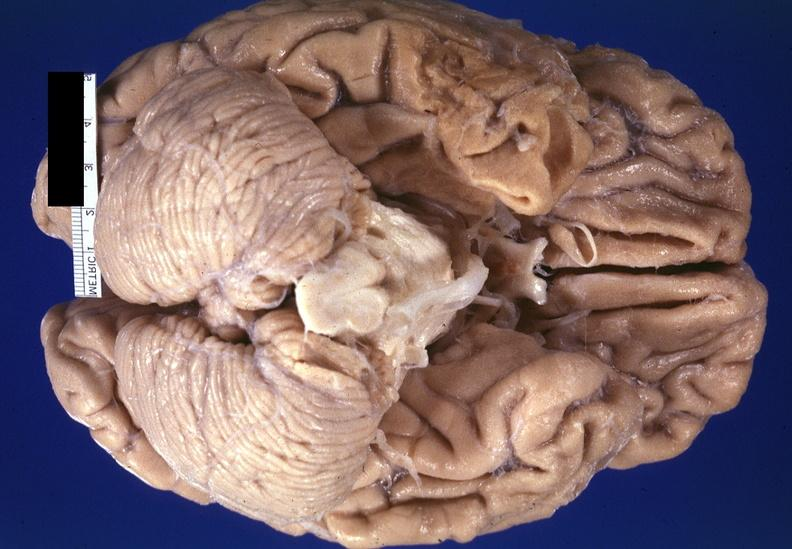what is present?
Answer the question using a single word or phrase. Nervous 